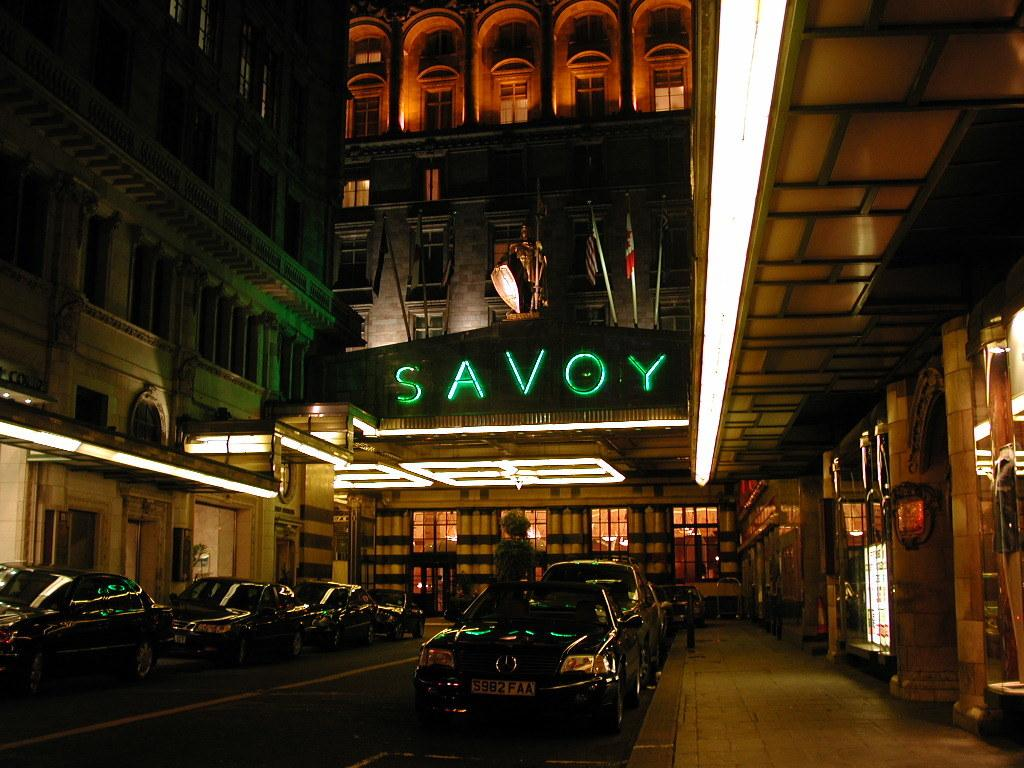What type of vehicles can be seen on the road in the image? There are cars on the road in the image. What else can be seen in the image besides the cars? There are buildings visible in the image. Are there any specific features on the buildings? Yes, there are lights in the image, and flags are present on a building in the background. What type of bean is growing on the building in the image? There is no bean growing on the building in the image; it features cars on the road, buildings, lights, and flags. What does the presence of the flags on the building suggest about the image? The presence of flags on the building does not inherently suggest any specific emotion or feeling, such as shame. 